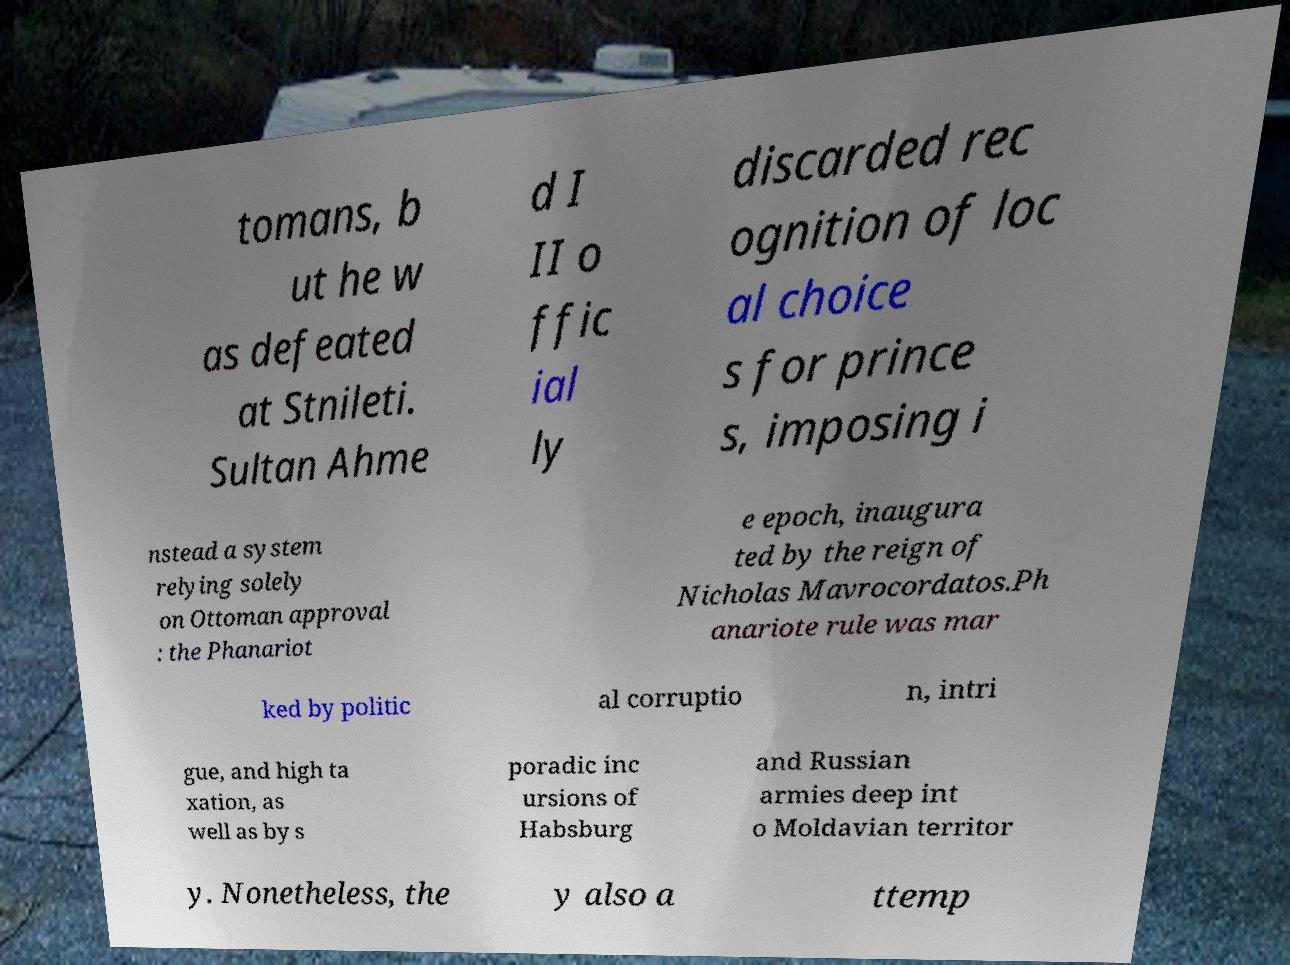Could you extract and type out the text from this image? tomans, b ut he w as defeated at Stnileti. Sultan Ahme d I II o ffic ial ly discarded rec ognition of loc al choice s for prince s, imposing i nstead a system relying solely on Ottoman approval : the Phanariot e epoch, inaugura ted by the reign of Nicholas Mavrocordatos.Ph anariote rule was mar ked by politic al corruptio n, intri gue, and high ta xation, as well as by s poradic inc ursions of Habsburg and Russian armies deep int o Moldavian territor y. Nonetheless, the y also a ttemp 